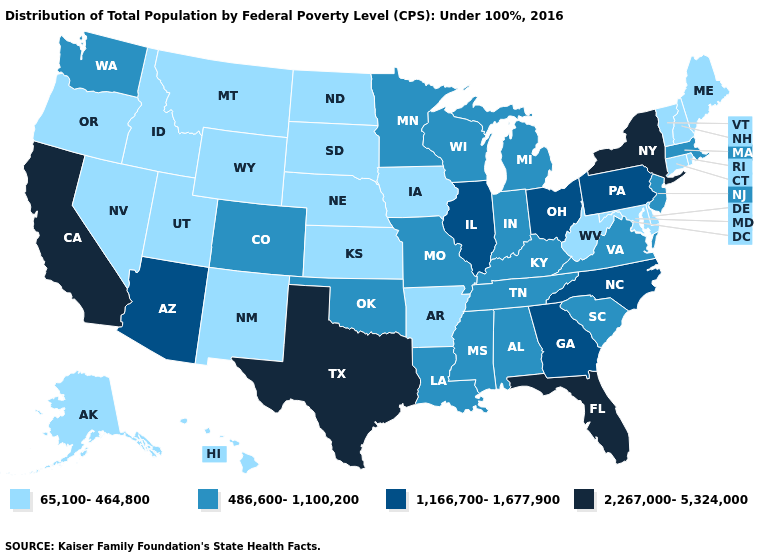Is the legend a continuous bar?
Be succinct. No. Does Virginia have the same value as Arizona?
Give a very brief answer. No. What is the value of Montana?
Short answer required. 65,100-464,800. How many symbols are there in the legend?
Keep it brief. 4. Does Montana have the highest value in the West?
Write a very short answer. No. What is the value of Tennessee?
Be succinct. 486,600-1,100,200. Does Montana have a lower value than Nevada?
Short answer required. No. Name the states that have a value in the range 65,100-464,800?
Give a very brief answer. Alaska, Arkansas, Connecticut, Delaware, Hawaii, Idaho, Iowa, Kansas, Maine, Maryland, Montana, Nebraska, Nevada, New Hampshire, New Mexico, North Dakota, Oregon, Rhode Island, South Dakota, Utah, Vermont, West Virginia, Wyoming. Among the states that border North Dakota , which have the lowest value?
Give a very brief answer. Montana, South Dakota. Which states have the lowest value in the MidWest?
Write a very short answer. Iowa, Kansas, Nebraska, North Dakota, South Dakota. What is the value of South Carolina?
Quick response, please. 486,600-1,100,200. What is the value of South Dakota?
Answer briefly. 65,100-464,800. Does Michigan have the highest value in the USA?
Give a very brief answer. No. What is the highest value in the West ?
Concise answer only. 2,267,000-5,324,000. 